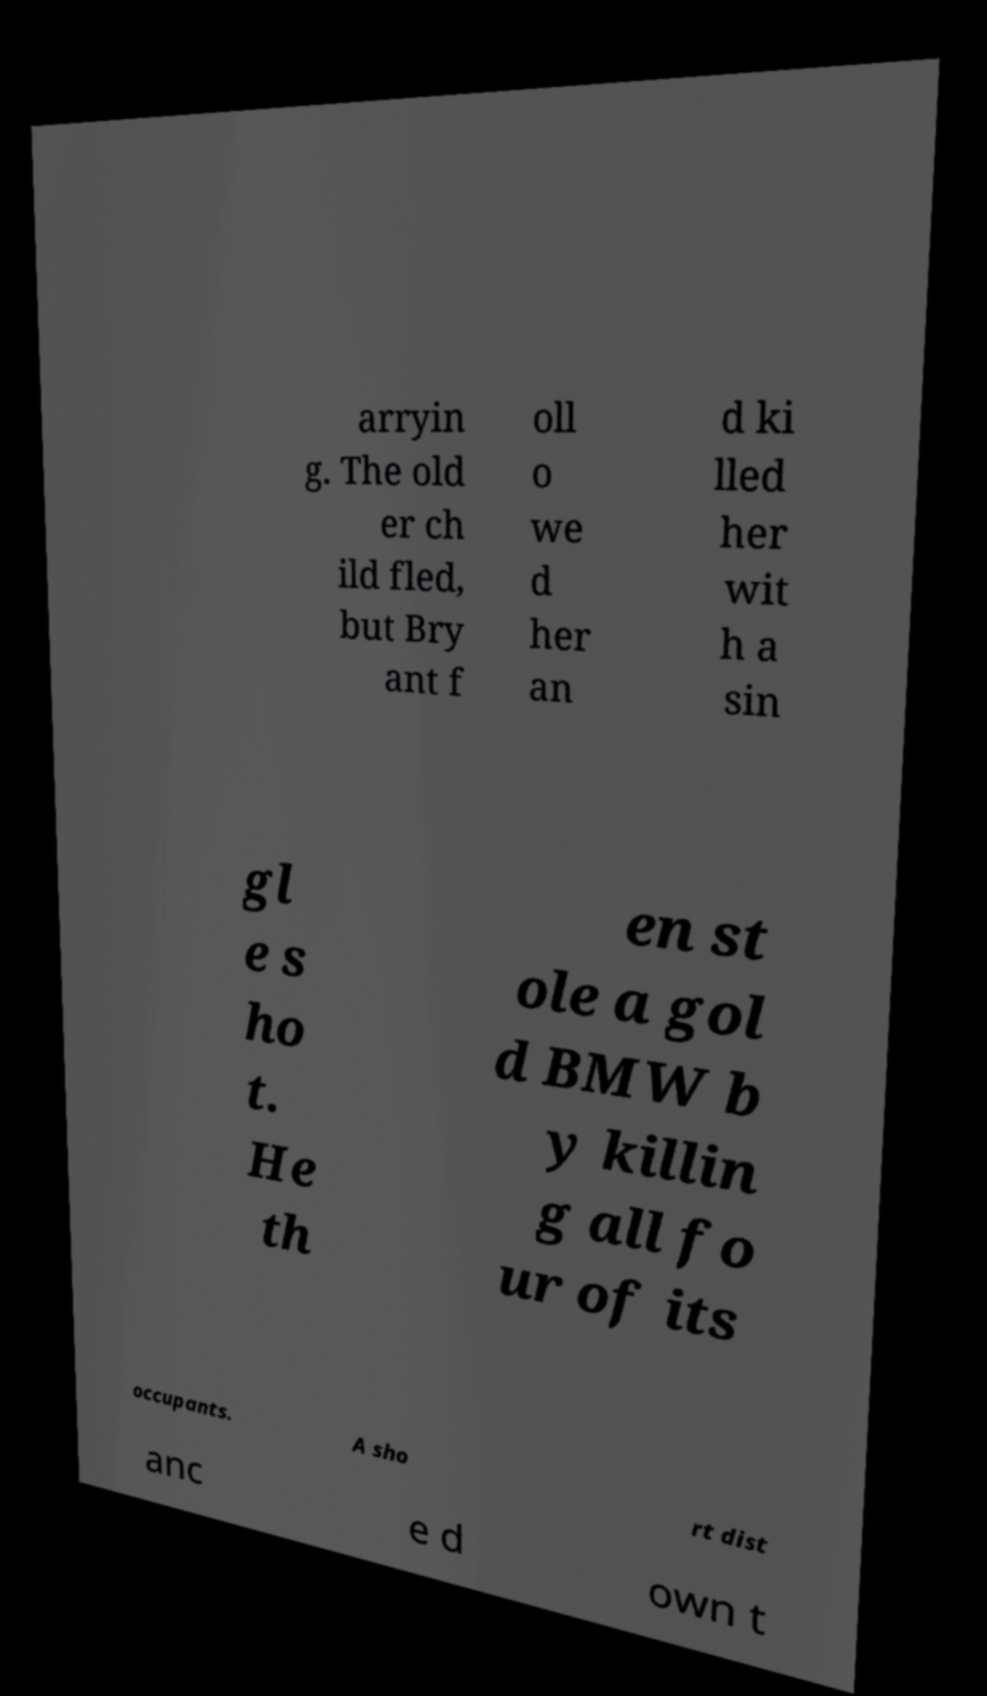For documentation purposes, I need the text within this image transcribed. Could you provide that? arryin g. The old er ch ild fled, but Bry ant f oll o we d her an d ki lled her wit h a sin gl e s ho t. He th en st ole a gol d BMW b y killin g all fo ur of its occupants. A sho rt dist anc e d own t 